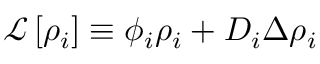Convert formula to latex. <formula><loc_0><loc_0><loc_500><loc_500>\mathcal { L } \left [ \rho _ { i } \right ] \equiv \phi _ { i } \rho _ { i } + D _ { i } \Delta \rho _ { i }</formula> 